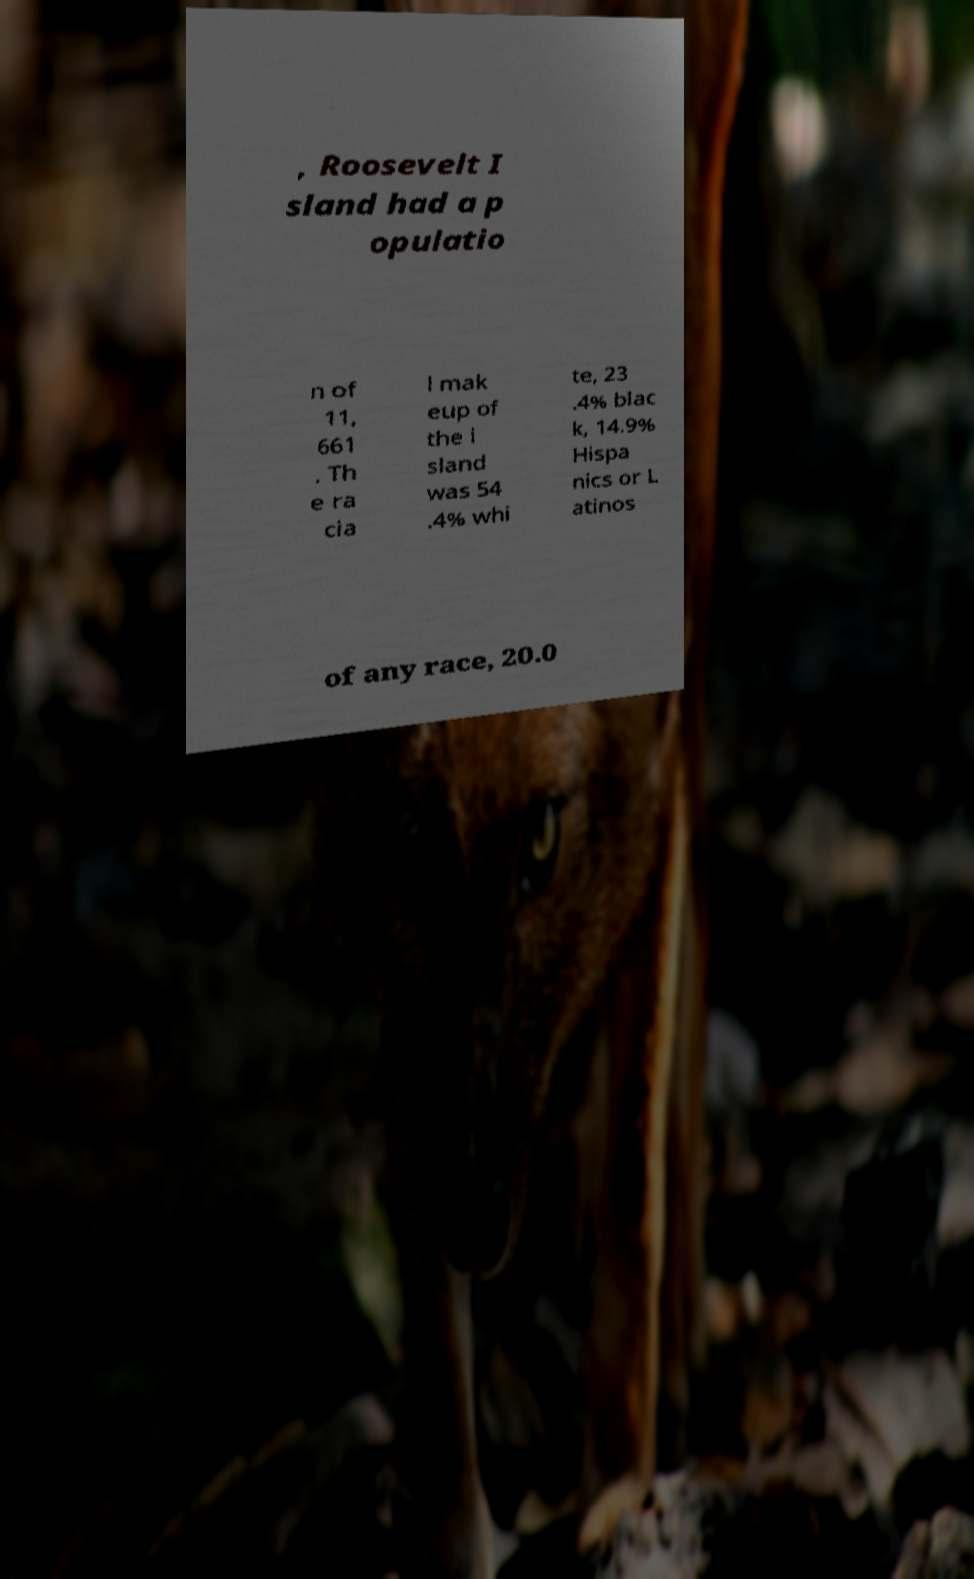Please identify and transcribe the text found in this image. , Roosevelt I sland had a p opulatio n of 11, 661 . Th e ra cia l mak eup of the i sland was 54 .4% whi te, 23 .4% blac k, 14.9% Hispa nics or L atinos of any race, 20.0 